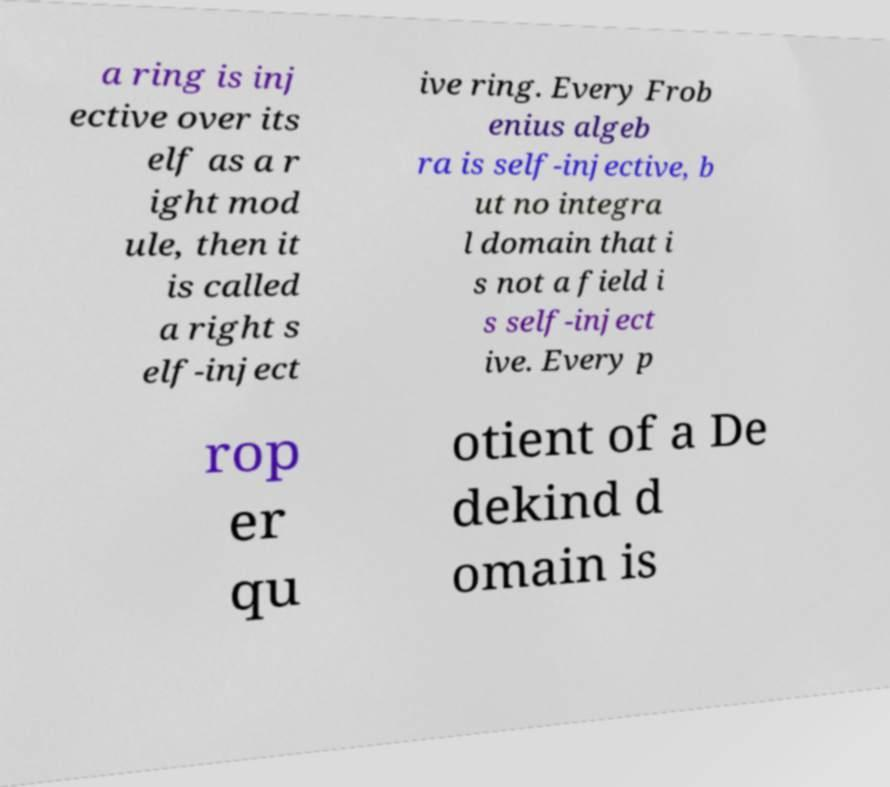Could you extract and type out the text from this image? a ring is inj ective over its elf as a r ight mod ule, then it is called a right s elf-inject ive ring. Every Frob enius algeb ra is self-injective, b ut no integra l domain that i s not a field i s self-inject ive. Every p rop er qu otient of a De dekind d omain is 